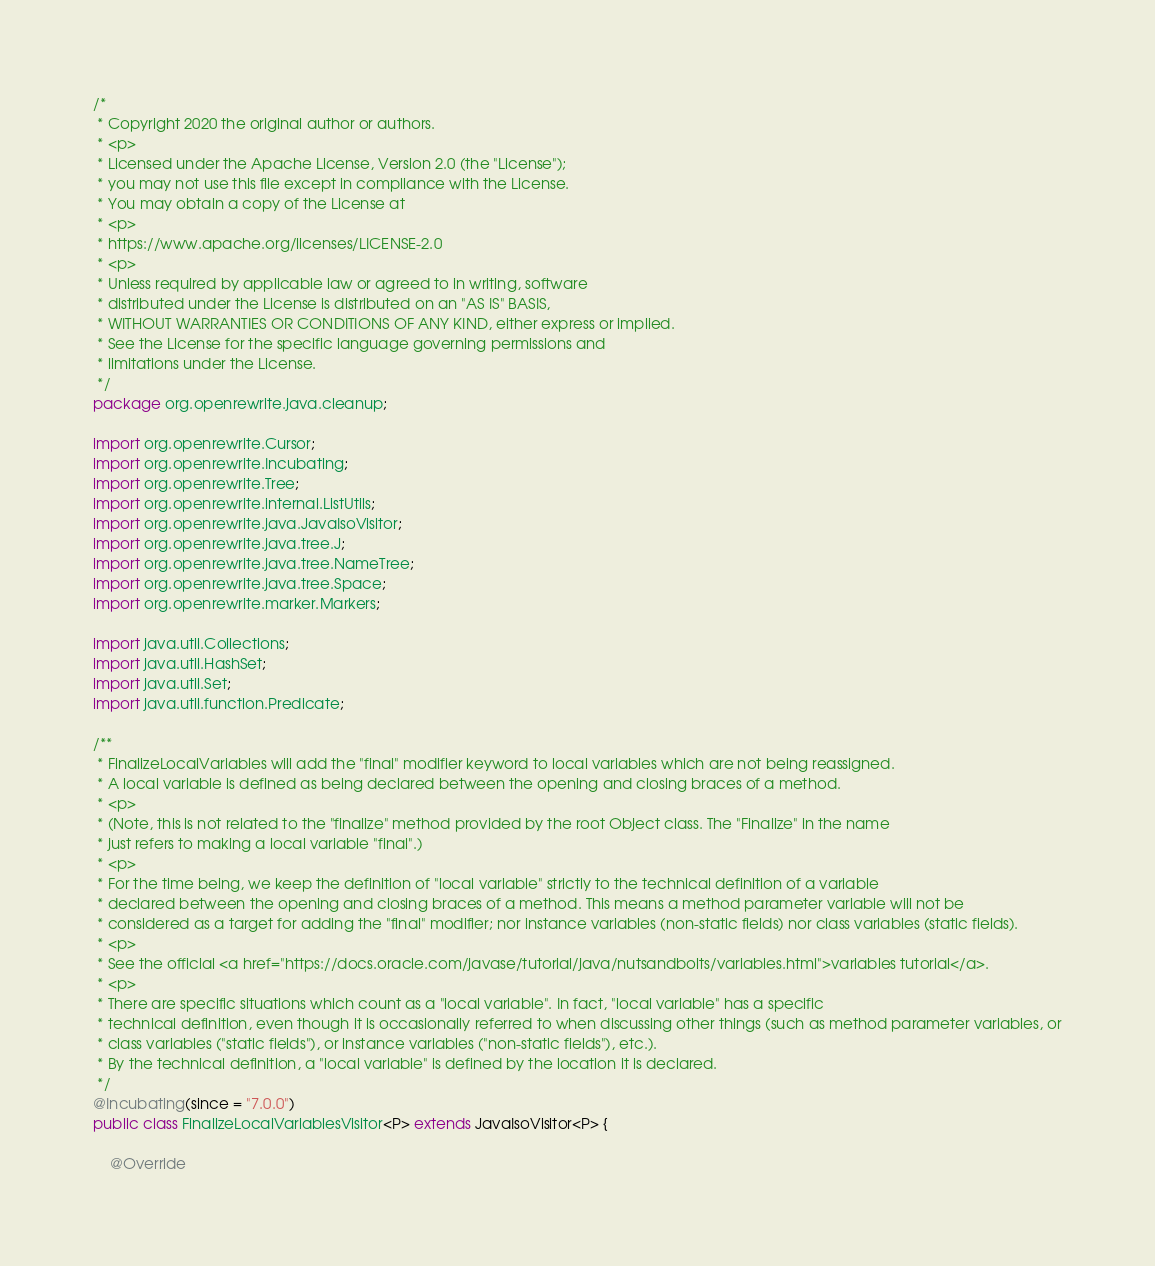Convert code to text. <code><loc_0><loc_0><loc_500><loc_500><_Java_>/*
 * Copyright 2020 the original author or authors.
 * <p>
 * Licensed under the Apache License, Version 2.0 (the "License");
 * you may not use this file except in compliance with the License.
 * You may obtain a copy of the License at
 * <p>
 * https://www.apache.org/licenses/LICENSE-2.0
 * <p>
 * Unless required by applicable law or agreed to in writing, software
 * distributed under the License is distributed on an "AS IS" BASIS,
 * WITHOUT WARRANTIES OR CONDITIONS OF ANY KIND, either express or implied.
 * See the License for the specific language governing permissions and
 * limitations under the License.
 */
package org.openrewrite.java.cleanup;

import org.openrewrite.Cursor;
import org.openrewrite.Incubating;
import org.openrewrite.Tree;
import org.openrewrite.internal.ListUtils;
import org.openrewrite.java.JavaIsoVisitor;
import org.openrewrite.java.tree.J;
import org.openrewrite.java.tree.NameTree;
import org.openrewrite.java.tree.Space;
import org.openrewrite.marker.Markers;

import java.util.Collections;
import java.util.HashSet;
import java.util.Set;
import java.util.function.Predicate;

/**
 * FinalizeLocalVariables will add the "final" modifier keyword to local variables which are not being reassigned.
 * A local variable is defined as being declared between the opening and closing braces of a method.
 * <p>
 * (Note, this is not related to the "finalize" method provided by the root Object class. The "Finalize" in the name
 * just refers to making a local variable "final".)
 * <p>
 * For the time being, we keep the definition of "local variable" strictly to the technical definition of a variable
 * declared between the opening and closing braces of a method. This means a method parameter variable will not be
 * considered as a target for adding the "final" modifier; nor instance variables (non-static fields) nor class variables (static fields).
 * <p>
 * See the official <a href="https://docs.oracle.com/javase/tutorial/java/nutsandbolts/variables.html">variables tutorial</a>.
 * <p>
 * There are specific situations which count as a "local variable". In fact, "local variable" has a specific
 * technical definition, even though it is occasionally referred to when discussing other things (such as method parameter variables, or
 * class variables ("static fields"), or instance variables ("non-static fields"), etc.).
 * By the technical definition, a "local variable" is defined by the location it is declared.
 */
@Incubating(since = "7.0.0")
public class FinalizeLocalVariablesVisitor<P> extends JavaIsoVisitor<P> {

    @Override</code> 